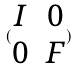Convert formula to latex. <formula><loc_0><loc_0><loc_500><loc_500>( \begin{matrix} I & 0 \\ 0 & F \end{matrix} )</formula> 